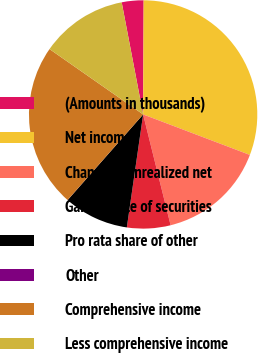Convert chart to OTSL. <chart><loc_0><loc_0><loc_500><loc_500><pie_chart><fcel>(Amounts in thousands)<fcel>Net income<fcel>Change in unrealized net<fcel>Gain on sale of securities<fcel>Pro rata share of other<fcel>Other<fcel>Comprehensive income<fcel>Less comprehensive income<nl><fcel>3.08%<fcel>30.7%<fcel>15.36%<fcel>6.15%<fcel>9.22%<fcel>0.01%<fcel>23.19%<fcel>12.29%<nl></chart> 